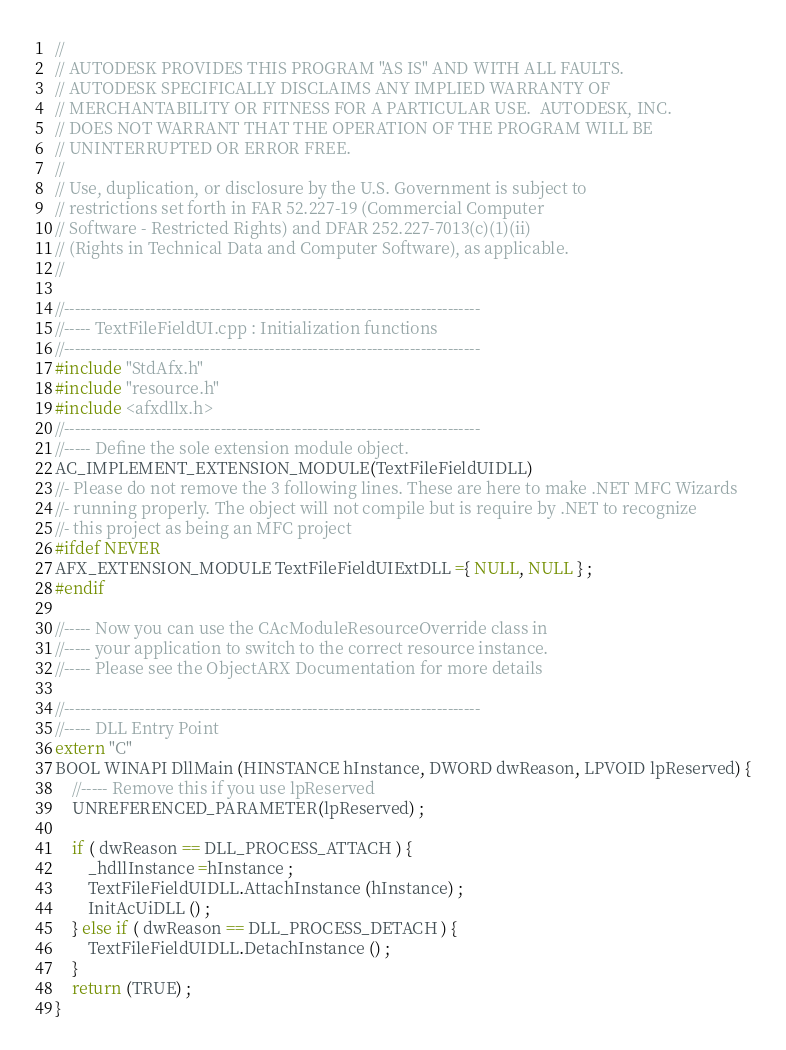Convert code to text. <code><loc_0><loc_0><loc_500><loc_500><_C++_>//
// AUTODESK PROVIDES THIS PROGRAM "AS IS" AND WITH ALL FAULTS. 
// AUTODESK SPECIFICALLY DISCLAIMS ANY IMPLIED WARRANTY OF
// MERCHANTABILITY OR FITNESS FOR A PARTICULAR USE.  AUTODESK, INC. 
// DOES NOT WARRANT THAT THE OPERATION OF THE PROGRAM WILL BE
// UNINTERRUPTED OR ERROR FREE.
//
// Use, duplication, or disclosure by the U.S. Government is subject to 
// restrictions set forth in FAR 52.227-19 (Commercial Computer
// Software - Restricted Rights) and DFAR 252.227-7013(c)(1)(ii)
// (Rights in Technical Data and Computer Software), as applicable.
//

//-----------------------------------------------------------------------------
//----- TextFileFieldUI.cpp : Initialization functions
//-----------------------------------------------------------------------------
#include "StdAfx.h"
#include "resource.h"
#include <afxdllx.h>
//-----------------------------------------------------------------------------
//----- Define the sole extension module object.
AC_IMPLEMENT_EXTENSION_MODULE(TextFileFieldUIDLL)
//- Please do not remove the 3 following lines. These are here to make .NET MFC Wizards
//- running properly. The object will not compile but is require by .NET to recognize
//- this project as being an MFC project
#ifdef NEVER
AFX_EXTENSION_MODULE TextFileFieldUIExtDLL ={ NULL, NULL } ;
#endif

//----- Now you can use the CAcModuleResourceOverride class in
//----- your application to switch to the correct resource instance.
//----- Please see the ObjectARX Documentation for more details

//-----------------------------------------------------------------------------
//----- DLL Entry Point
extern "C"
BOOL WINAPI DllMain (HINSTANCE hInstance, DWORD dwReason, LPVOID lpReserved) {
	//----- Remove this if you use lpReserved
	UNREFERENCED_PARAMETER(lpReserved) ;

	if ( dwReason == DLL_PROCESS_ATTACH ) {
        _hdllInstance =hInstance ;
		TextFileFieldUIDLL.AttachInstance (hInstance) ;
		InitAcUiDLL () ;
	} else if ( dwReason == DLL_PROCESS_DETACH ) {
		TextFileFieldUIDLL.DetachInstance () ;
	}
	return (TRUE) ;
}

</code> 